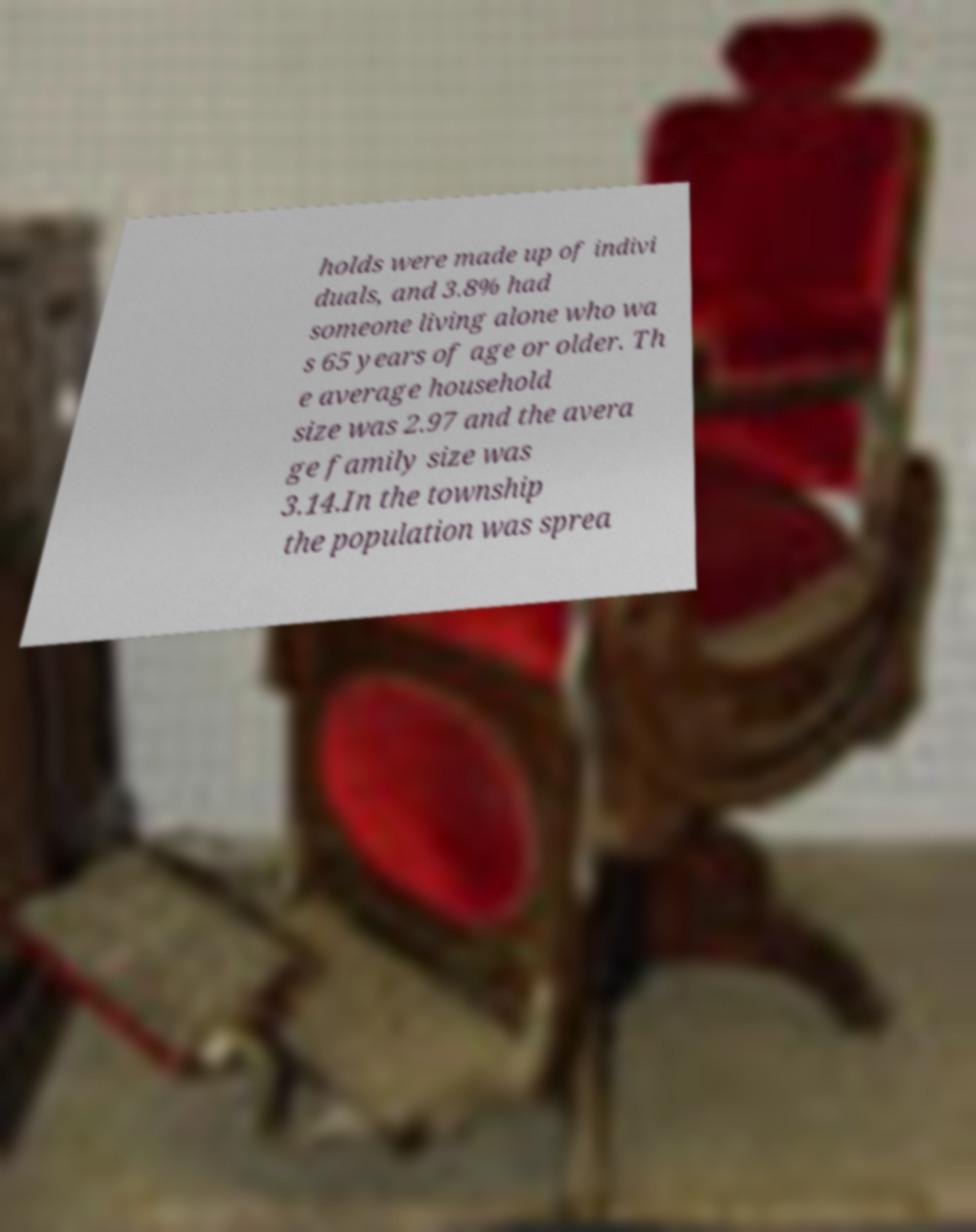I need the written content from this picture converted into text. Can you do that? holds were made up of indivi duals, and 3.8% had someone living alone who wa s 65 years of age or older. Th e average household size was 2.97 and the avera ge family size was 3.14.In the township the population was sprea 